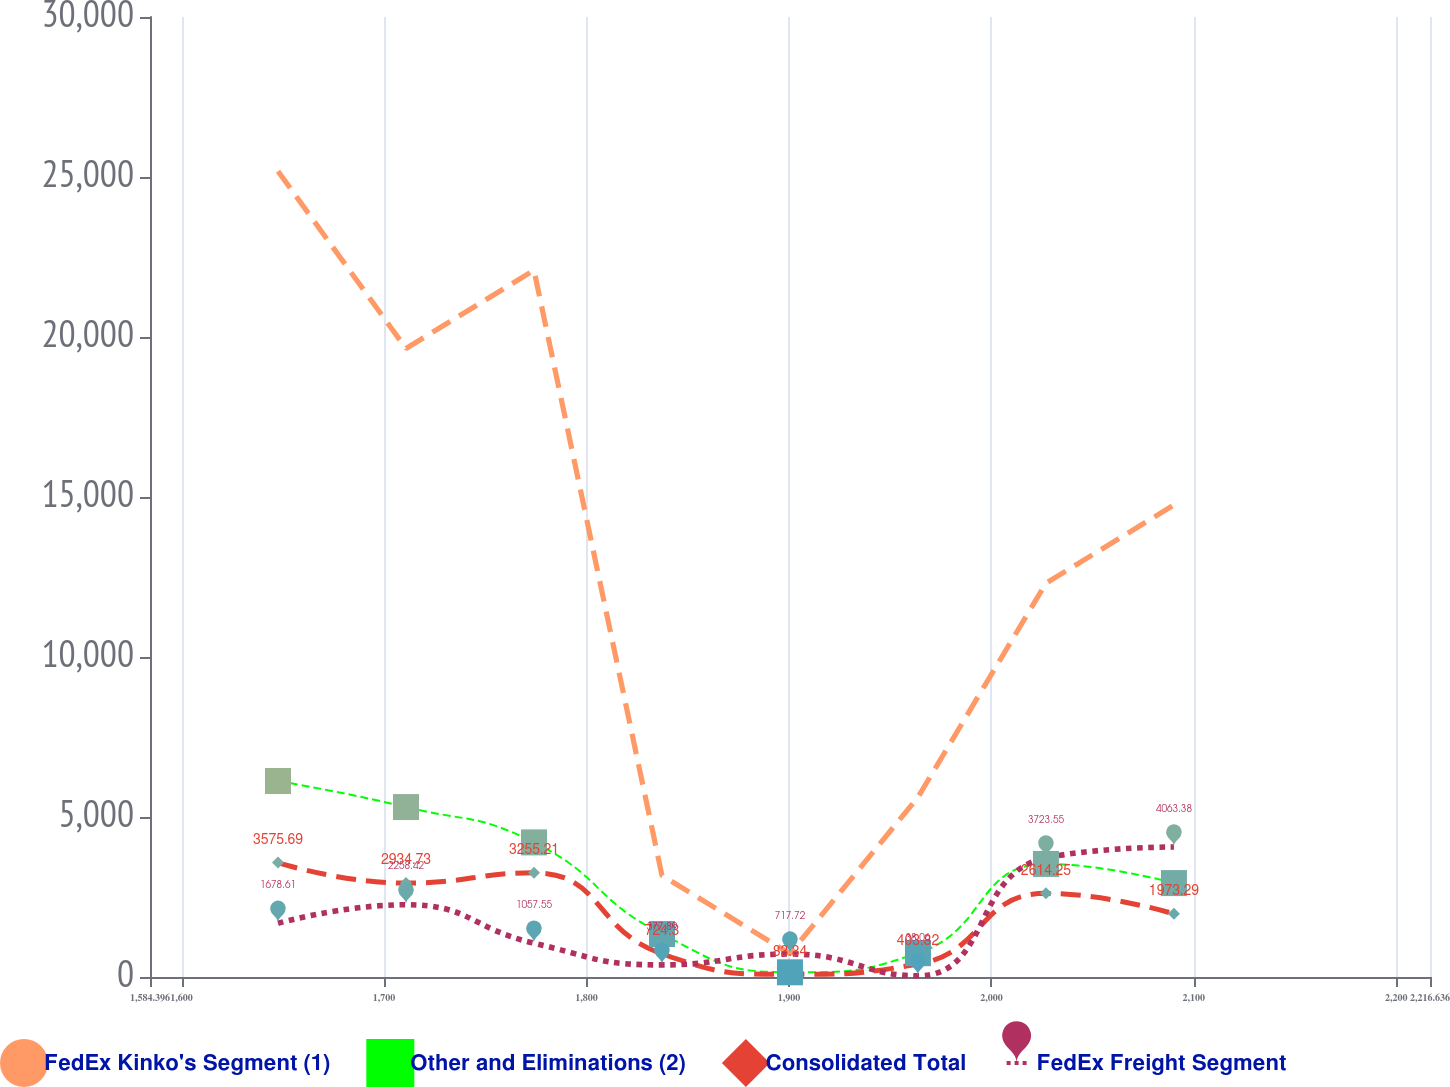Convert chart. <chart><loc_0><loc_0><loc_500><loc_500><line_chart><ecel><fcel>FedEx Kinko's Segment (1)<fcel>Other and Eliminations (2)<fcel>Consolidated Total<fcel>FedEx Freight Segment<nl><fcel>1647.62<fcel>25180.2<fcel>6124.44<fcel>3575.69<fcel>1678.61<nl><fcel>1710.84<fcel>19641.3<fcel>5310.74<fcel>2934.73<fcel>2258.42<nl><fcel>1774.06<fcel>22086.6<fcel>4206.27<fcel>3255.21<fcel>1057.55<nl><fcel>1837.28<fcel>3172.72<fcel>1342.22<fcel>724.3<fcel>377.89<nl><fcel>1900.5<fcel>727.45<fcel>146.66<fcel>83.34<fcel>717.72<nl><fcel>1963.72<fcel>5617.99<fcel>744.44<fcel>403.82<fcel>38.06<nl><fcel>2026.94<fcel>12305.5<fcel>3532.91<fcel>2614.25<fcel>3723.55<nl><fcel>2090.16<fcel>14750.8<fcel>2935.13<fcel>1973.29<fcel>4063.38<nl><fcel>2279.86<fcel>17196<fcel>2337.35<fcel>2293.77<fcel>3383.72<nl></chart> 